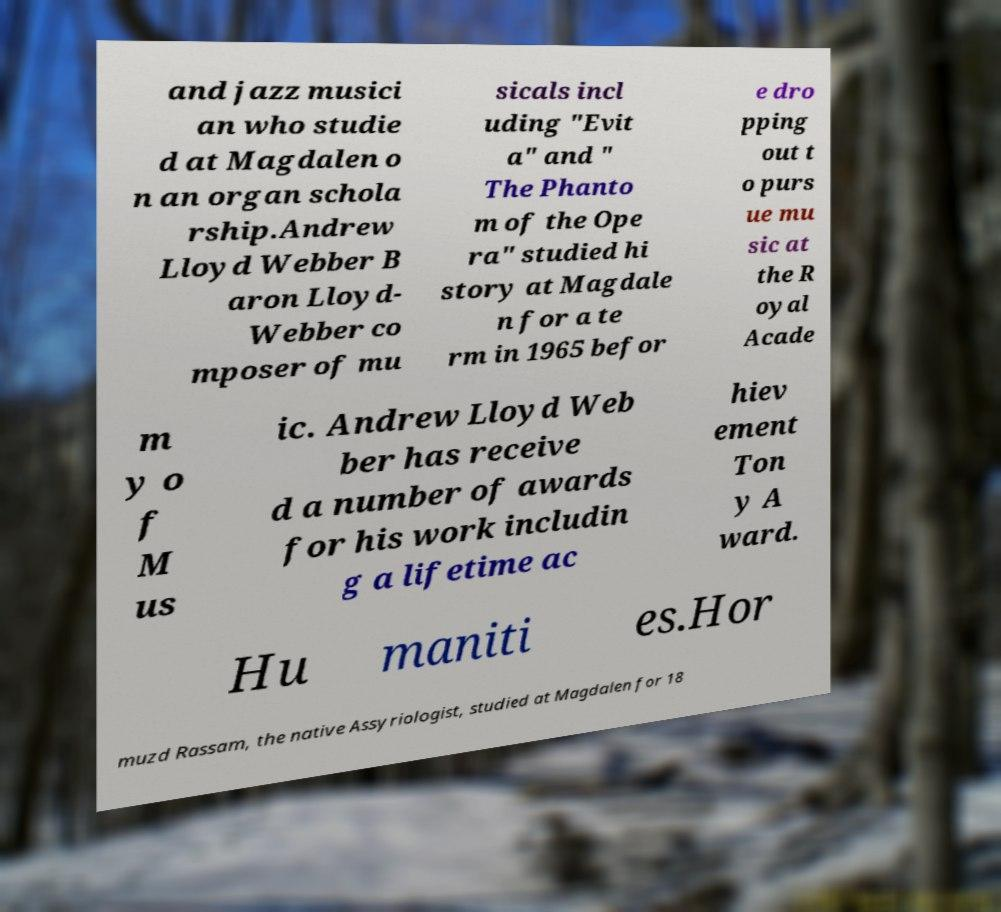Please identify and transcribe the text found in this image. and jazz musici an who studie d at Magdalen o n an organ schola rship.Andrew Lloyd Webber B aron Lloyd- Webber co mposer of mu sicals incl uding "Evit a" and " The Phanto m of the Ope ra" studied hi story at Magdale n for a te rm in 1965 befor e dro pping out t o purs ue mu sic at the R oyal Acade m y o f M us ic. Andrew Lloyd Web ber has receive d a number of awards for his work includin g a lifetime ac hiev ement Ton y A ward. Hu maniti es.Hor muzd Rassam, the native Assyriologist, studied at Magdalen for 18 